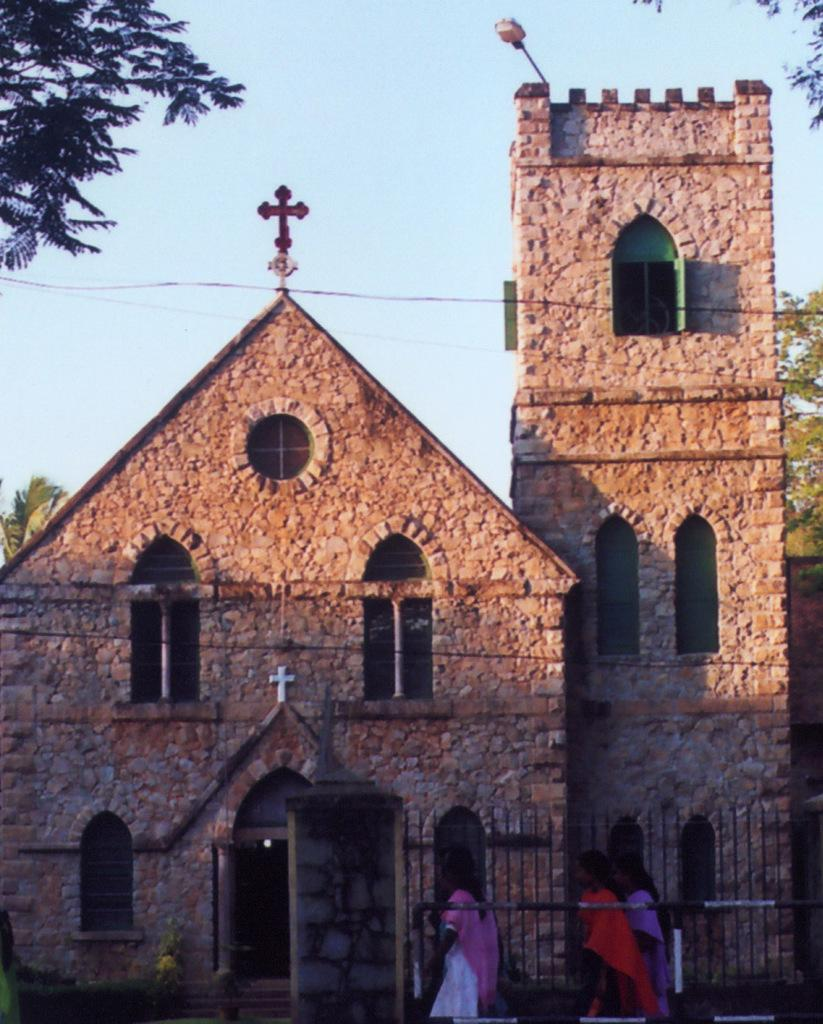What type of structure is present in the image? There is a building in the image. What religious symbols can be seen in the image? There are cross symbols in the image. Can you describe the lighting in the image? There is light visible in the image. What architectural feature is present in the image? There is a railing in the image. Who or what is present in the image? There are people in the image. What part of the natural environment is visible in the image? The sky and trees are visible in the image. What type of ticket is required to enter the building in the image? There is no mention of a ticket or any requirement for entry in the image. 